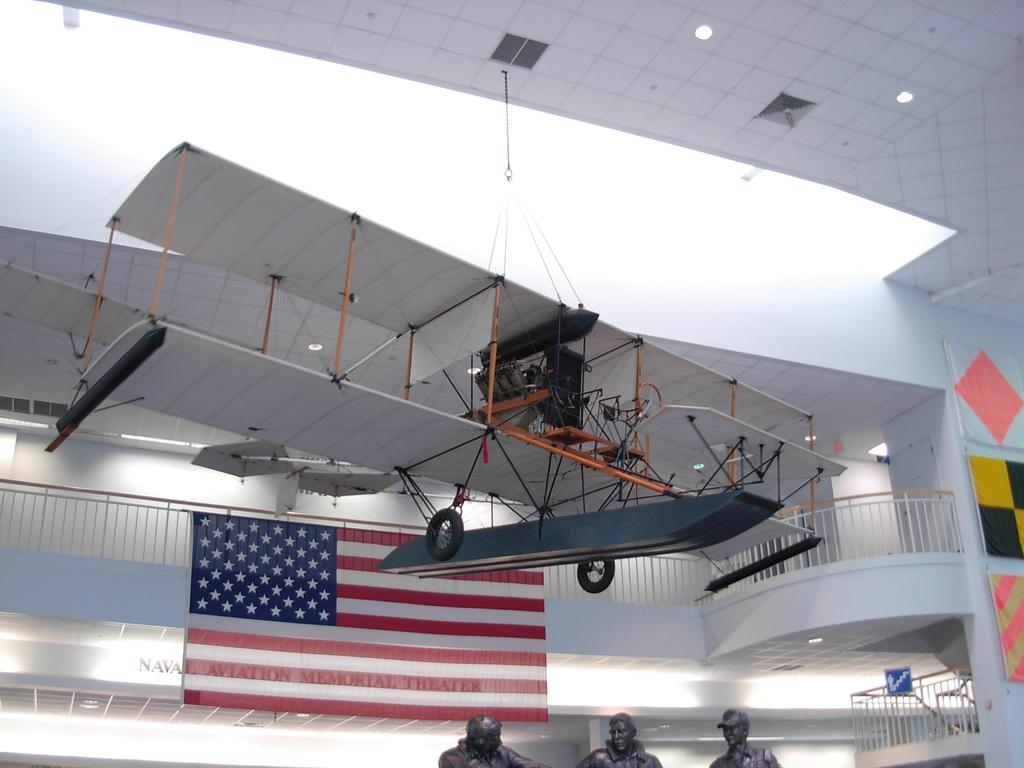How many person statues are at the bottom of the image? There are three person statues at the bottom of the image. What can be seen in the image besides the person statues? There is a fence, flags, a wall, a vehicle hung on a rooftop, and lights in the image. What might be used to separate or enclose an area in the image? The fence and wall in the image can be used to separate or enclose an area. What is the suspended object on the rooftop in the image? A vehicle is hanged on a rooftop in the image. What type of illumination is present in the image? There are lights in the image. Can you describe the possible location of the image? The image may have been taken in a hall. What type of volleyball game is being played in the image? There is no volleyball game present in the image. What emotion is the toad feeling in the image? There is no toad present in the image. 